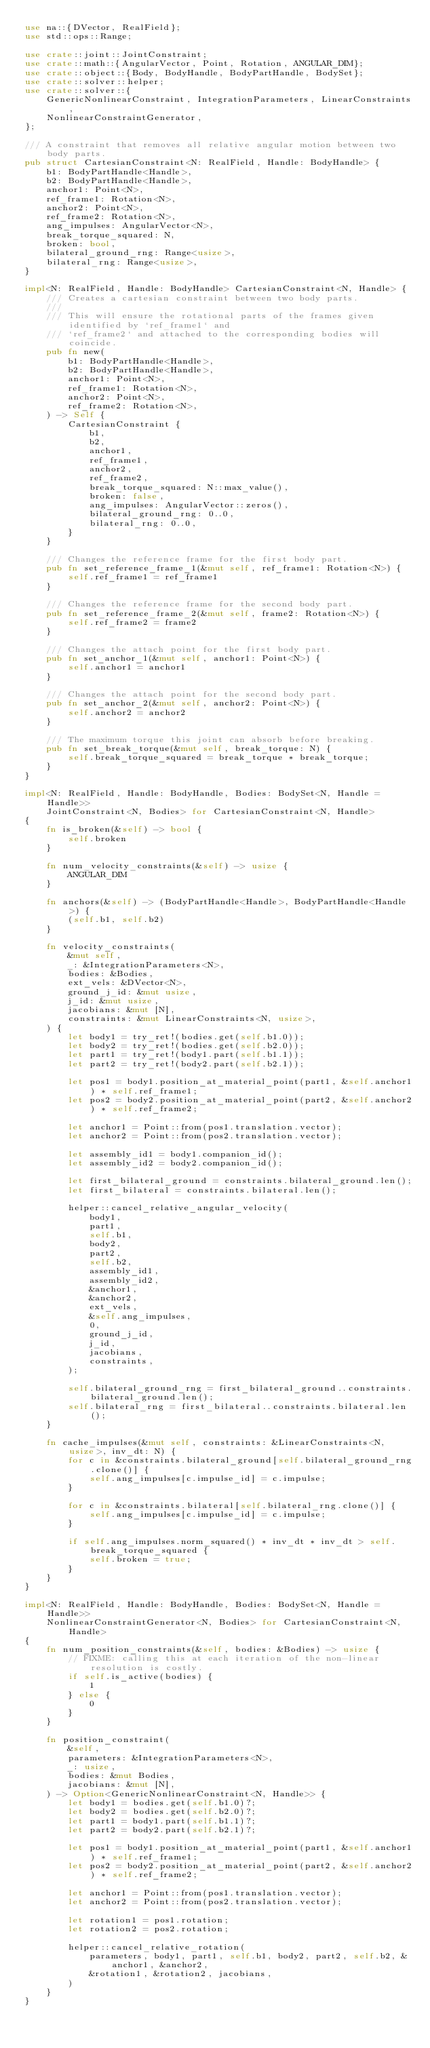<code> <loc_0><loc_0><loc_500><loc_500><_Rust_>use na::{DVector, RealField};
use std::ops::Range;

use crate::joint::JointConstraint;
use crate::math::{AngularVector, Point, Rotation, ANGULAR_DIM};
use crate::object::{Body, BodyHandle, BodyPartHandle, BodySet};
use crate::solver::helper;
use crate::solver::{
    GenericNonlinearConstraint, IntegrationParameters, LinearConstraints,
    NonlinearConstraintGenerator,
};

/// A constraint that removes all relative angular motion between two body parts.
pub struct CartesianConstraint<N: RealField, Handle: BodyHandle> {
    b1: BodyPartHandle<Handle>,
    b2: BodyPartHandle<Handle>,
    anchor1: Point<N>,
    ref_frame1: Rotation<N>,
    anchor2: Point<N>,
    ref_frame2: Rotation<N>,
    ang_impulses: AngularVector<N>,
    break_torque_squared: N,
    broken: bool,
    bilateral_ground_rng: Range<usize>,
    bilateral_rng: Range<usize>,
}

impl<N: RealField, Handle: BodyHandle> CartesianConstraint<N, Handle> {
    /// Creates a cartesian constraint between two body parts.
    ///
    /// This will ensure the rotational parts of the frames given identified by `ref_frame1` and
    /// `ref_frame2` and attached to the corresponding bodies will coincide.
    pub fn new(
        b1: BodyPartHandle<Handle>,
        b2: BodyPartHandle<Handle>,
        anchor1: Point<N>,
        ref_frame1: Rotation<N>,
        anchor2: Point<N>,
        ref_frame2: Rotation<N>,
    ) -> Self {
        CartesianConstraint {
            b1,
            b2,
            anchor1,
            ref_frame1,
            anchor2,
            ref_frame2,
            break_torque_squared: N::max_value(),
            broken: false,
            ang_impulses: AngularVector::zeros(),
            bilateral_ground_rng: 0..0,
            bilateral_rng: 0..0,
        }
    }

    /// Changes the reference frame for the first body part.
    pub fn set_reference_frame_1(&mut self, ref_frame1: Rotation<N>) {
        self.ref_frame1 = ref_frame1
    }

    /// Changes the reference frame for the second body part.
    pub fn set_reference_frame_2(&mut self, frame2: Rotation<N>) {
        self.ref_frame2 = frame2
    }

    /// Changes the attach point for the first body part.
    pub fn set_anchor_1(&mut self, anchor1: Point<N>) {
        self.anchor1 = anchor1
    }

    /// Changes the attach point for the second body part.
    pub fn set_anchor_2(&mut self, anchor2: Point<N>) {
        self.anchor2 = anchor2
    }

    /// The maximum torque this joint can absorb before breaking.
    pub fn set_break_torque(&mut self, break_torque: N) {
        self.break_torque_squared = break_torque * break_torque;
    }
}

impl<N: RealField, Handle: BodyHandle, Bodies: BodySet<N, Handle = Handle>>
    JointConstraint<N, Bodies> for CartesianConstraint<N, Handle>
{
    fn is_broken(&self) -> bool {
        self.broken
    }

    fn num_velocity_constraints(&self) -> usize {
        ANGULAR_DIM
    }

    fn anchors(&self) -> (BodyPartHandle<Handle>, BodyPartHandle<Handle>) {
        (self.b1, self.b2)
    }

    fn velocity_constraints(
        &mut self,
        _: &IntegrationParameters<N>,
        bodies: &Bodies,
        ext_vels: &DVector<N>,
        ground_j_id: &mut usize,
        j_id: &mut usize,
        jacobians: &mut [N],
        constraints: &mut LinearConstraints<N, usize>,
    ) {
        let body1 = try_ret!(bodies.get(self.b1.0));
        let body2 = try_ret!(bodies.get(self.b2.0));
        let part1 = try_ret!(body1.part(self.b1.1));
        let part2 = try_ret!(body2.part(self.b2.1));

        let pos1 = body1.position_at_material_point(part1, &self.anchor1) * self.ref_frame1;
        let pos2 = body2.position_at_material_point(part2, &self.anchor2) * self.ref_frame2;

        let anchor1 = Point::from(pos1.translation.vector);
        let anchor2 = Point::from(pos2.translation.vector);

        let assembly_id1 = body1.companion_id();
        let assembly_id2 = body2.companion_id();

        let first_bilateral_ground = constraints.bilateral_ground.len();
        let first_bilateral = constraints.bilateral.len();

        helper::cancel_relative_angular_velocity(
            body1,
            part1,
            self.b1,
            body2,
            part2,
            self.b2,
            assembly_id1,
            assembly_id2,
            &anchor1,
            &anchor2,
            ext_vels,
            &self.ang_impulses,
            0,
            ground_j_id,
            j_id,
            jacobians,
            constraints,
        );

        self.bilateral_ground_rng = first_bilateral_ground..constraints.bilateral_ground.len();
        self.bilateral_rng = first_bilateral..constraints.bilateral.len();
    }

    fn cache_impulses(&mut self, constraints: &LinearConstraints<N, usize>, inv_dt: N) {
        for c in &constraints.bilateral_ground[self.bilateral_ground_rng.clone()] {
            self.ang_impulses[c.impulse_id] = c.impulse;
        }

        for c in &constraints.bilateral[self.bilateral_rng.clone()] {
            self.ang_impulses[c.impulse_id] = c.impulse;
        }

        if self.ang_impulses.norm_squared() * inv_dt * inv_dt > self.break_torque_squared {
            self.broken = true;
        }
    }
}

impl<N: RealField, Handle: BodyHandle, Bodies: BodySet<N, Handle = Handle>>
    NonlinearConstraintGenerator<N, Bodies> for CartesianConstraint<N, Handle>
{
    fn num_position_constraints(&self, bodies: &Bodies) -> usize {
        // FIXME: calling this at each iteration of the non-linear resolution is costly.
        if self.is_active(bodies) {
            1
        } else {
            0
        }
    }

    fn position_constraint(
        &self,
        parameters: &IntegrationParameters<N>,
        _: usize,
        bodies: &mut Bodies,
        jacobians: &mut [N],
    ) -> Option<GenericNonlinearConstraint<N, Handle>> {
        let body1 = bodies.get(self.b1.0)?;
        let body2 = bodies.get(self.b2.0)?;
        let part1 = body1.part(self.b1.1)?;
        let part2 = body2.part(self.b2.1)?;

        let pos1 = body1.position_at_material_point(part1, &self.anchor1) * self.ref_frame1;
        let pos2 = body2.position_at_material_point(part2, &self.anchor2) * self.ref_frame2;

        let anchor1 = Point::from(pos1.translation.vector);
        let anchor2 = Point::from(pos2.translation.vector);

        let rotation1 = pos1.rotation;
        let rotation2 = pos2.rotation;

        helper::cancel_relative_rotation(
            parameters, body1, part1, self.b1, body2, part2, self.b2, &anchor1, &anchor2,
            &rotation1, &rotation2, jacobians,
        )
    }
}
</code> 